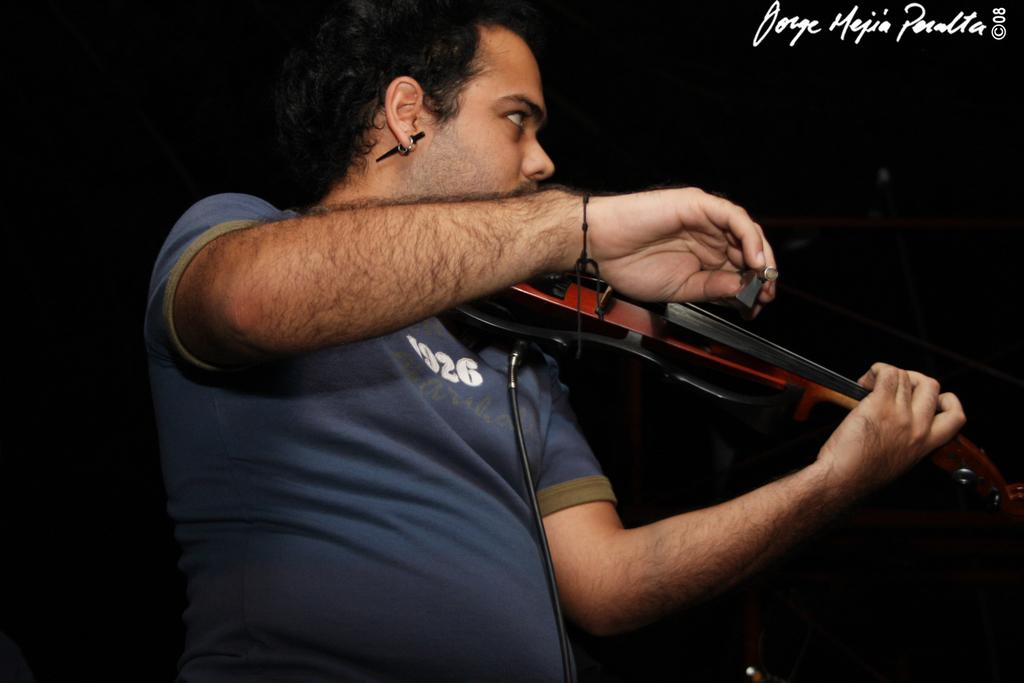What is the main subject of the image? There is a man in the image. What is the man doing in the image? The man is holding a musical instrument. How many roots can be seen growing from the man's feet in the image? There are no roots visible in the image; the man is holding a musical instrument. 